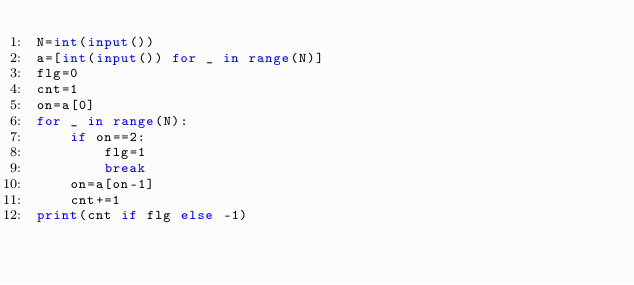<code> <loc_0><loc_0><loc_500><loc_500><_Python_>N=int(input())
a=[int(input()) for _ in range(N)]
flg=0
cnt=1
on=a[0]
for _ in range(N):
    if on==2:
        flg=1
        break
    on=a[on-1]
    cnt+=1
print(cnt if flg else -1)
    

</code> 